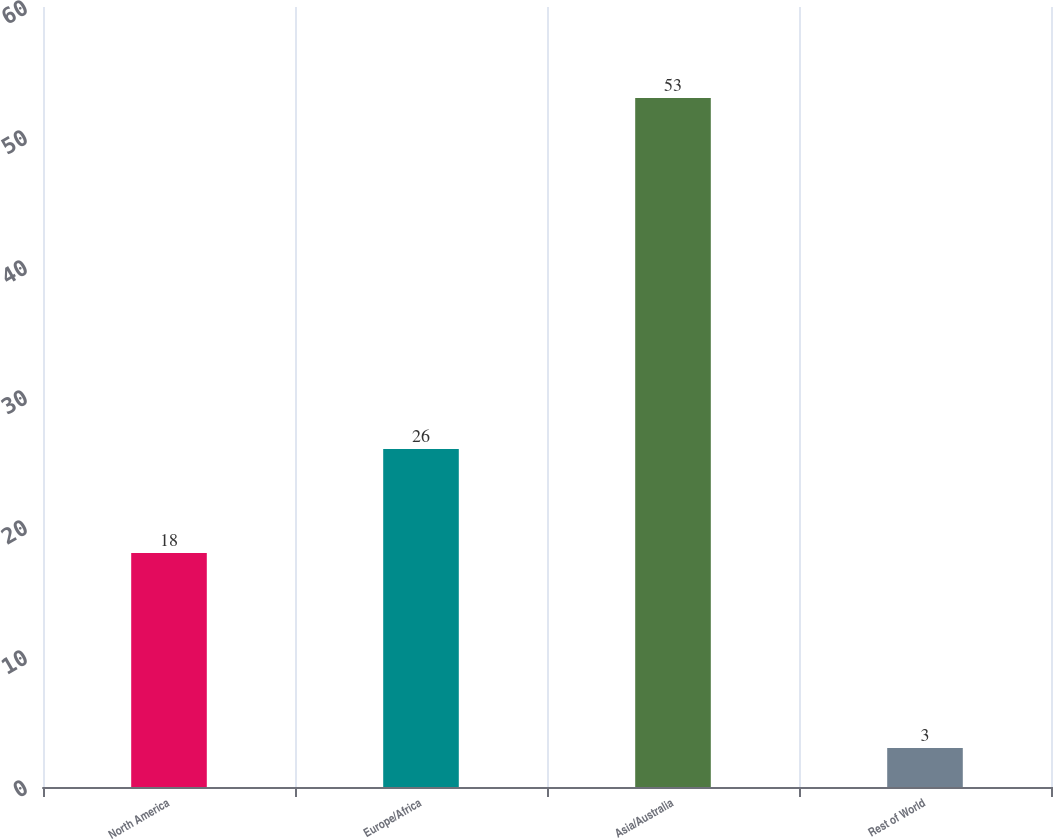<chart> <loc_0><loc_0><loc_500><loc_500><bar_chart><fcel>North America<fcel>Europe/Africa<fcel>Asia/Australia<fcel>Rest of World<nl><fcel>18<fcel>26<fcel>53<fcel>3<nl></chart> 